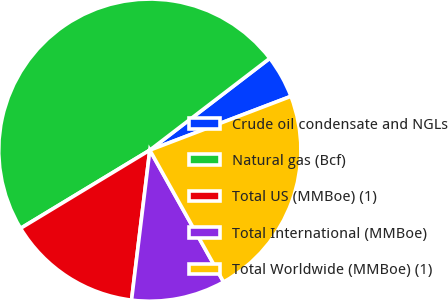Convert chart. <chart><loc_0><loc_0><loc_500><loc_500><pie_chart><fcel>Crude oil condensate and NGLs<fcel>Natural gas (Bcf)<fcel>Total US (MMBoe) (1)<fcel>Total International (MMBoe)<fcel>Total Worldwide (MMBoe) (1)<nl><fcel>4.6%<fcel>48.26%<fcel>14.41%<fcel>10.05%<fcel>22.68%<nl></chart> 